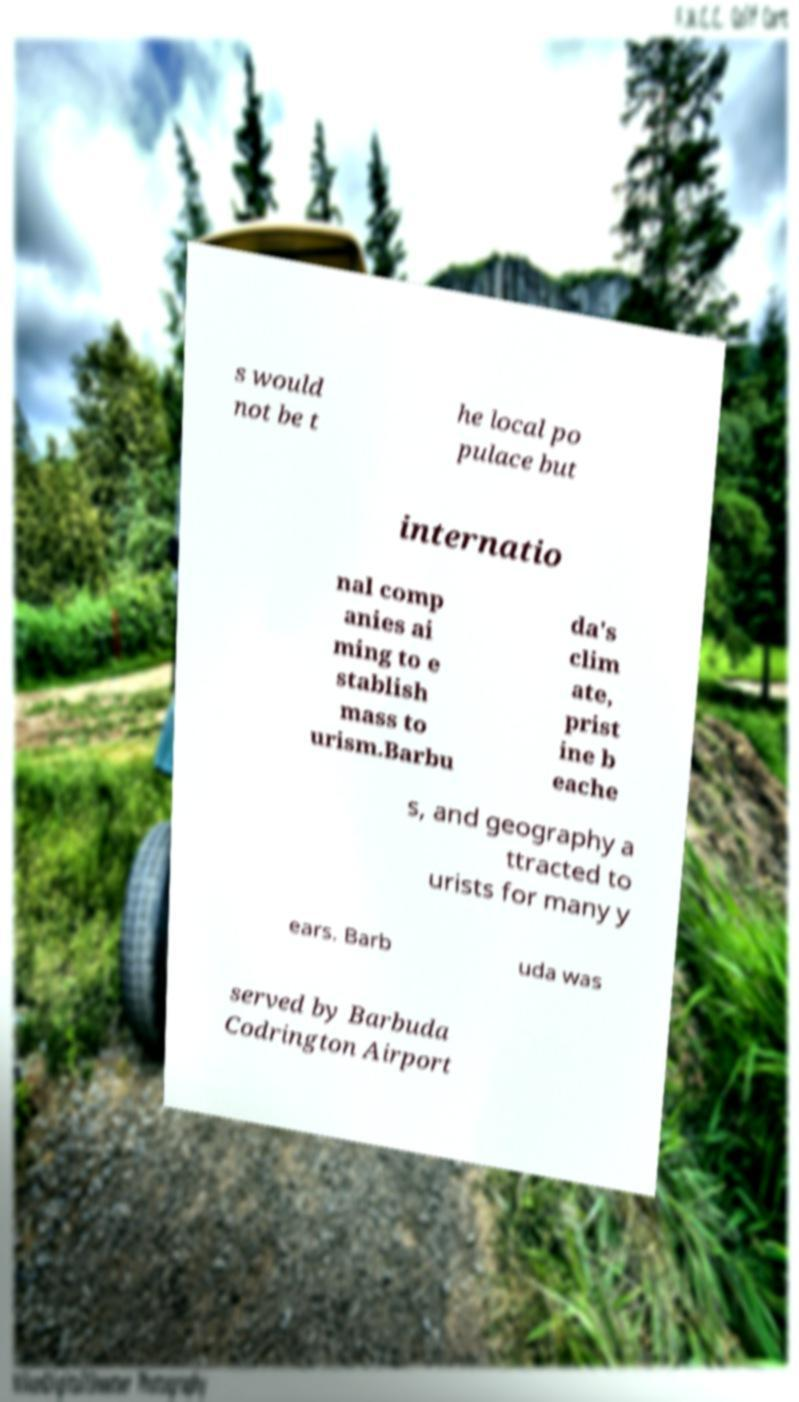What messages or text are displayed in this image? I need them in a readable, typed format. s would not be t he local po pulace but internatio nal comp anies ai ming to e stablish mass to urism.Barbu da's clim ate, prist ine b eache s, and geography a ttracted to urists for many y ears. Barb uda was served by Barbuda Codrington Airport 